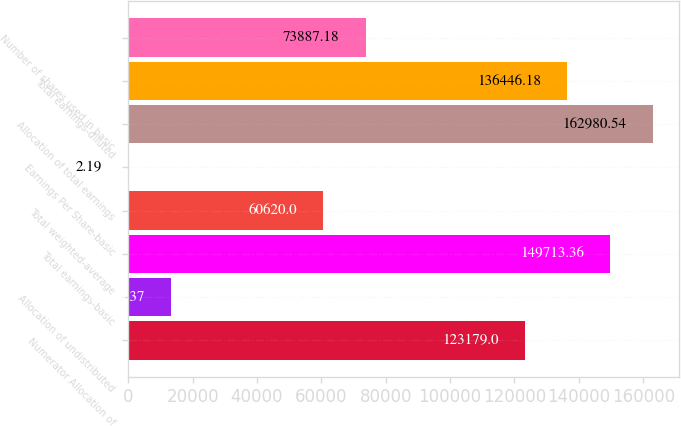Convert chart. <chart><loc_0><loc_0><loc_500><loc_500><bar_chart><fcel>Numerator Allocation of<fcel>Allocation of undistributed<fcel>Total earnings-basic<fcel>Total weighted-average<fcel>Earnings Per Share-basic<fcel>Allocation of total earnings<fcel>Total earnings-diluted<fcel>Number of shares used in basic<nl><fcel>123179<fcel>13269.4<fcel>149713<fcel>60620<fcel>2.19<fcel>162981<fcel>136446<fcel>73887.2<nl></chart> 